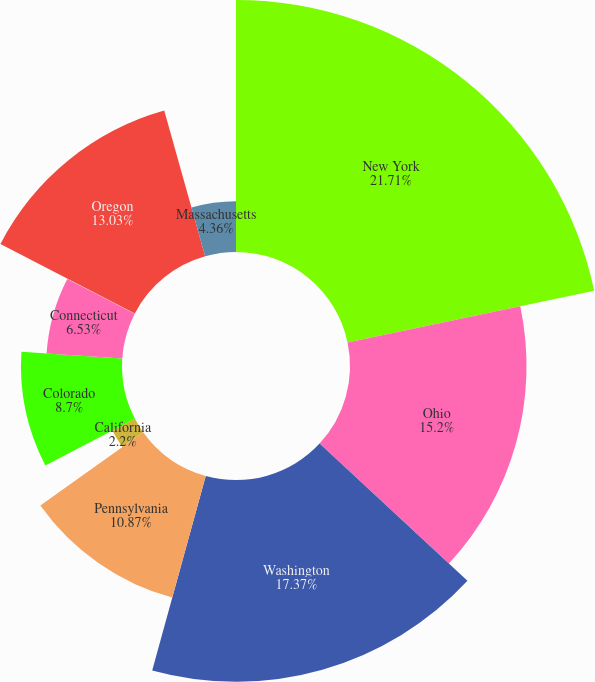Convert chart. <chart><loc_0><loc_0><loc_500><loc_500><pie_chart><fcel>New York<fcel>Ohio<fcel>Washington<fcel>Pennsylvania<fcel>California<fcel>Colorado<fcel>Connecticut<fcel>Texas<fcel>Oregon<fcel>Massachusetts<nl><fcel>21.7%<fcel>15.2%<fcel>17.37%<fcel>10.87%<fcel>2.2%<fcel>8.7%<fcel>6.53%<fcel>0.03%<fcel>13.03%<fcel>4.36%<nl></chart> 